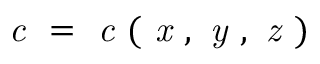<formula> <loc_0><loc_0><loc_500><loc_500>c = c ( x , y , z )</formula> 